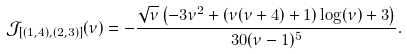Convert formula to latex. <formula><loc_0><loc_0><loc_500><loc_500>\mathcal { J } _ { [ ( 1 , 4 ) , ( 2 , 3 ) ] } ( \nu ) = - \frac { \sqrt { \nu } \left ( - 3 \nu ^ { 2 } + ( \nu ( \nu + 4 ) + 1 ) \log ( \nu ) + 3 \right ) } { 3 0 ( \nu - 1 ) ^ { 5 } } .</formula> 